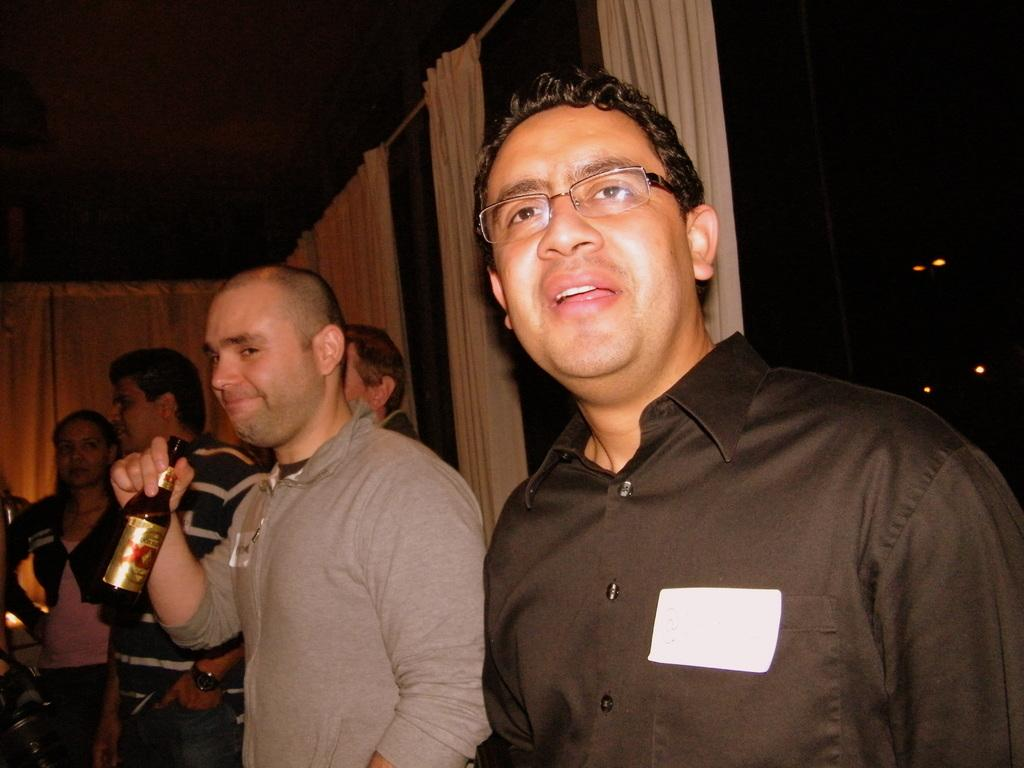What is the gender of the people standing in the image? There are men standing in the image. Are there any other people besides the men in the image? Yes, there are other people standing in the image. What is one of the men holding in the image? There is a man holding a wine bottle in the image. What songs are the babies singing in the image? There are no babies or songs present in the image. Is the queen visible in the image? There is no queen present in the image. 